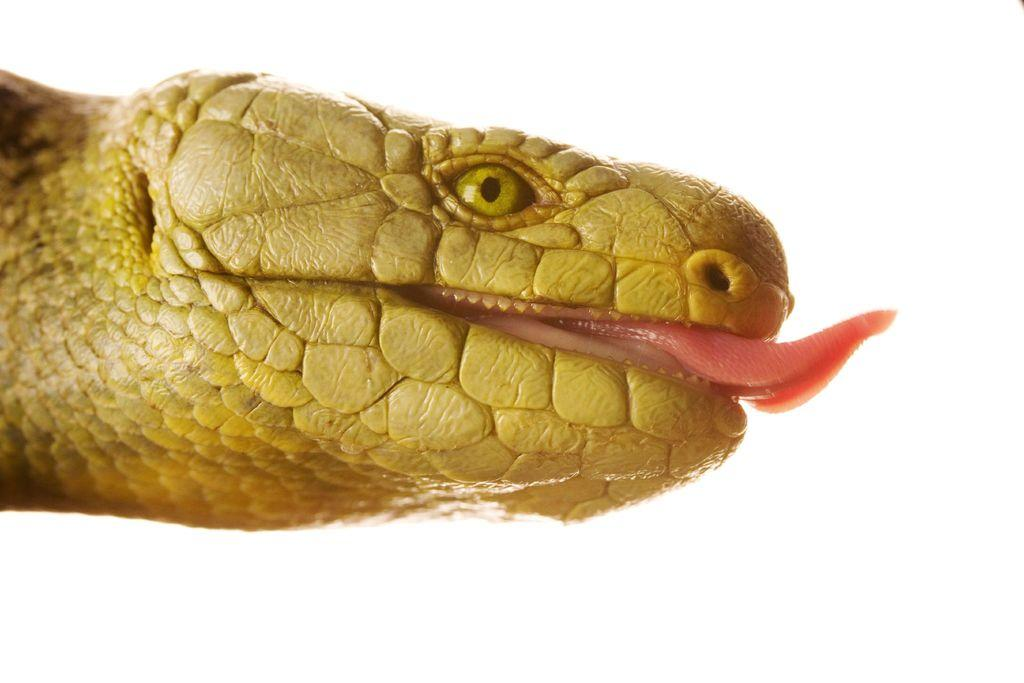What type of animal is in the image? There is a reptile in the image. What does the reptile resemble? The reptile looks like a snake. What color is the reptile? The reptile is in yellow color. What color is the background of the image? The background of the image is white in color. How many brothers does the snake have in the image? There are no brothers mentioned or depicted in the image, as it features a reptile that resembles a snake. What type of footwear is the snake wearing in the image? There is no footwear present in the image, as it features a reptile that resembles a snake. 